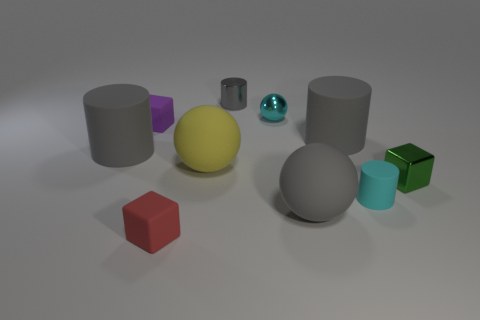How would you describe the lighting in the image? The lighting in the image seems soft and diffused, with shadows that are gently cast, indicating a source of light that is neither too harsh nor too direct. It helps to highlight the textures and dimensions of the objects without creating overly sharp contrasts. 